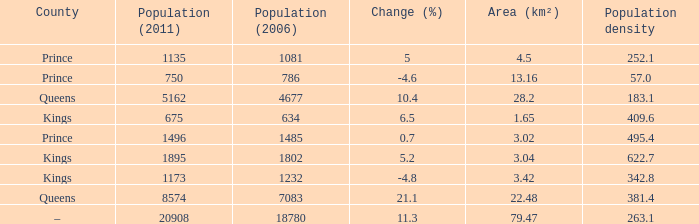4, and a population (2011) under 8574, in queens county? None. 